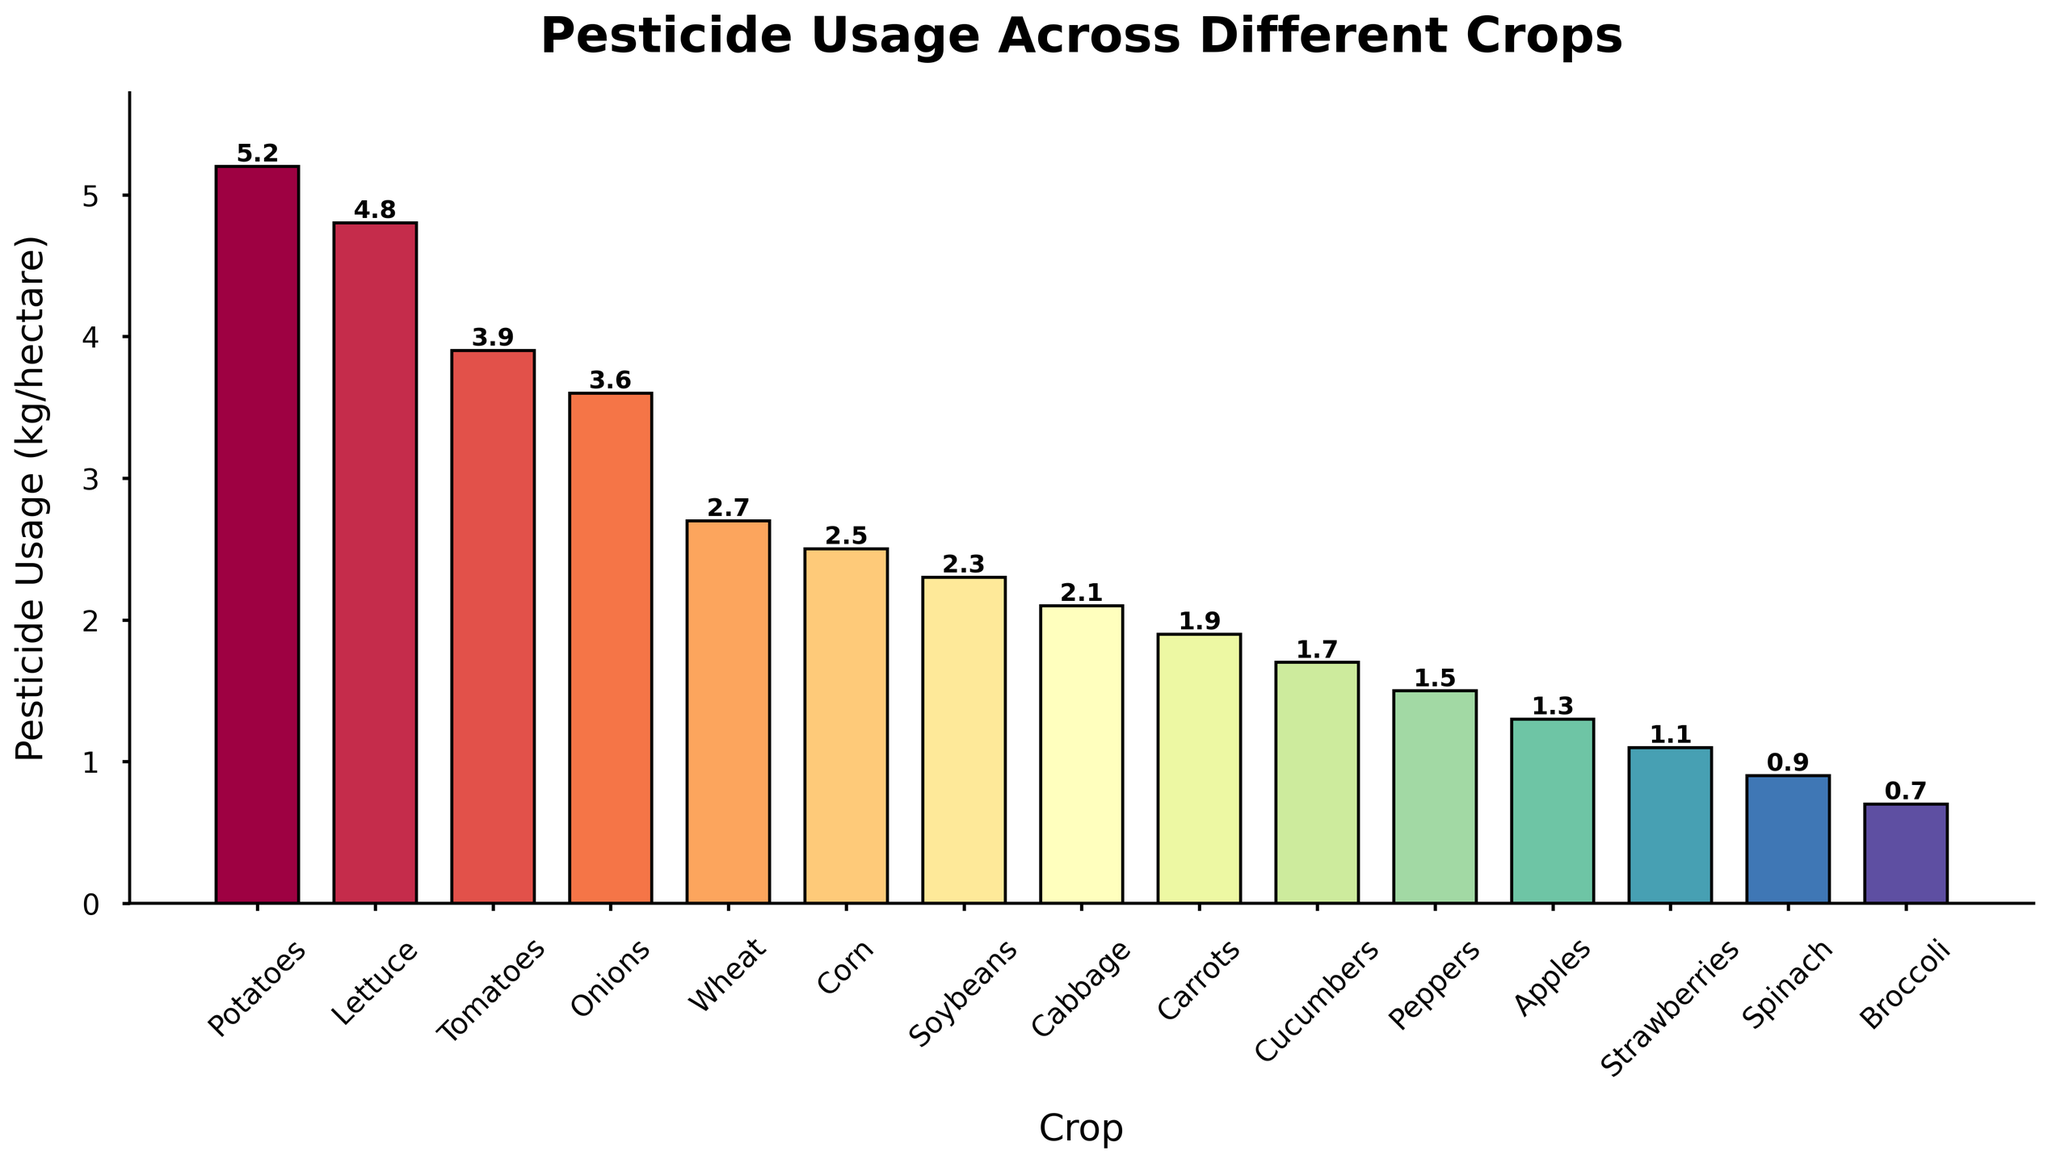Which crop has the highest pesticide usage? The bar representing Potatoes is the tallest, indicating it has the highest pesticide usage.
Answer: Potatoes Which crop has the lowest pesticide usage? The bar representing Broccoli is the shortest, indicating it has the lowest pesticide usage.
Answer: Broccoli What is the difference in pesticide usage between Potatoes and Tomatoes? Subtract the pesticide usage of Tomatoes (3.9) from that of Potatoes (5.2). 5.2 - 3.9 = 1.3
Answer: 1.3 Which crop uses more pesticide, Onions or Lettuce? The bar for Lettuce is slightly taller than the bar for Onions, indicating Lettuce uses more pesticide.
Answer: Lettuce What is the average pesticide usage across all crops? Sum all the pesticide usage values and divide by the number of crops: (5.2 + 4.8 + 3.9 + 3.6 + 2.7 + 2.5 + 2.3 + 2.1 + 1.9 + 1.7 + 1.5 + 1.3 + 1.1 + 0.9 + 0.7) / 15 = 2.46
Answer: 2.46 Which two crops have the closest pesticide usage values? The values for Soybeans (2.3) and Cabbage (2.1) are very close to each other, with a difference of only 0.2.
Answer: Soybeans and Cabbage How much more pesticide is used on Potatoes than on Spinach? Subtract the pesticide usage of Spinach (0.9) from that of Potatoes (5.2). 5.2 - 0.9 = 4.3
Answer: 4.3 If the pesticide usage on Wheat were to double, would it surpass that of Tomatoes? Doubling Wheat's pesticide usage, 2 x 2.7 = 5.4, which is greater than Tomatoes' 3.9.
Answer: Yes Rank the top three crops by pesticide usage. The three tallest bars represent Potatoes (5.2), Lettuce (4.8), and Tomatoes (3.9), in that order.
Answer: Potatoes, Lettuce, Tomatoes What is the median pesticide usage value? Arrange the pesticide usage values in ascending order and find the middle value: (0.7, 0.9, 1.1, 1.3, 1.5, 1.7, 1.9, 2.1, 2.3, 2.5, 2.7, 3.6, 3.9, 4.8, 5.2). The middle value is 2.1.
Answer: 2.1 